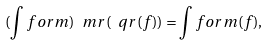<formula> <loc_0><loc_0><loc_500><loc_500>( \int f o r m ) ^ { \ } m r ( \ q r ( f ) ) = \int f o r m ( f ) ,</formula> 